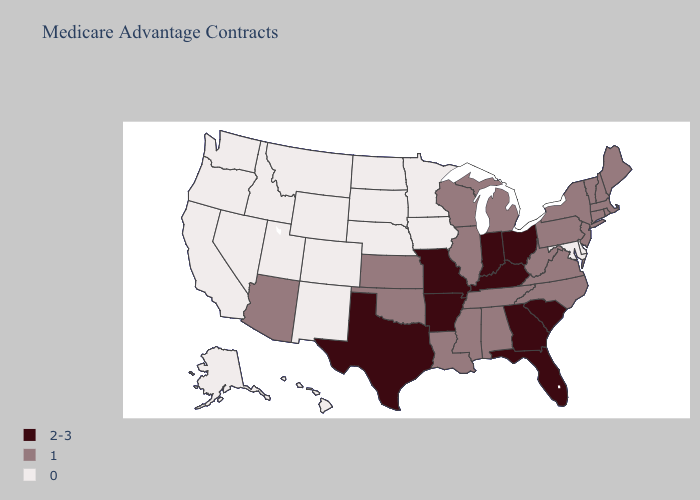What is the value of Georgia?
Answer briefly. 2-3. What is the lowest value in states that border Alabama?
Keep it brief. 1. What is the highest value in states that border Maine?
Be succinct. 1. What is the value of Tennessee?
Be succinct. 1. Which states have the highest value in the USA?
Keep it brief. Arkansas, Florida, Georgia, Indiana, Kentucky, Missouri, Ohio, South Carolina, Texas. What is the value of North Carolina?
Concise answer only. 1. Name the states that have a value in the range 1?
Concise answer only. Alabama, Arizona, Connecticut, Illinois, Kansas, Louisiana, Massachusetts, Maine, Michigan, Mississippi, North Carolina, New Hampshire, New Jersey, New York, Oklahoma, Pennsylvania, Rhode Island, Tennessee, Virginia, Vermont, Wisconsin, West Virginia. Is the legend a continuous bar?
Concise answer only. No. Does Missouri have a higher value than Indiana?
Be succinct. No. Which states hav the highest value in the West?
Give a very brief answer. Arizona. What is the value of New Mexico?
Be succinct. 0. Does Wisconsin have a lower value than South Carolina?
Short answer required. Yes. Among the states that border South Carolina , which have the lowest value?
Keep it brief. North Carolina. 